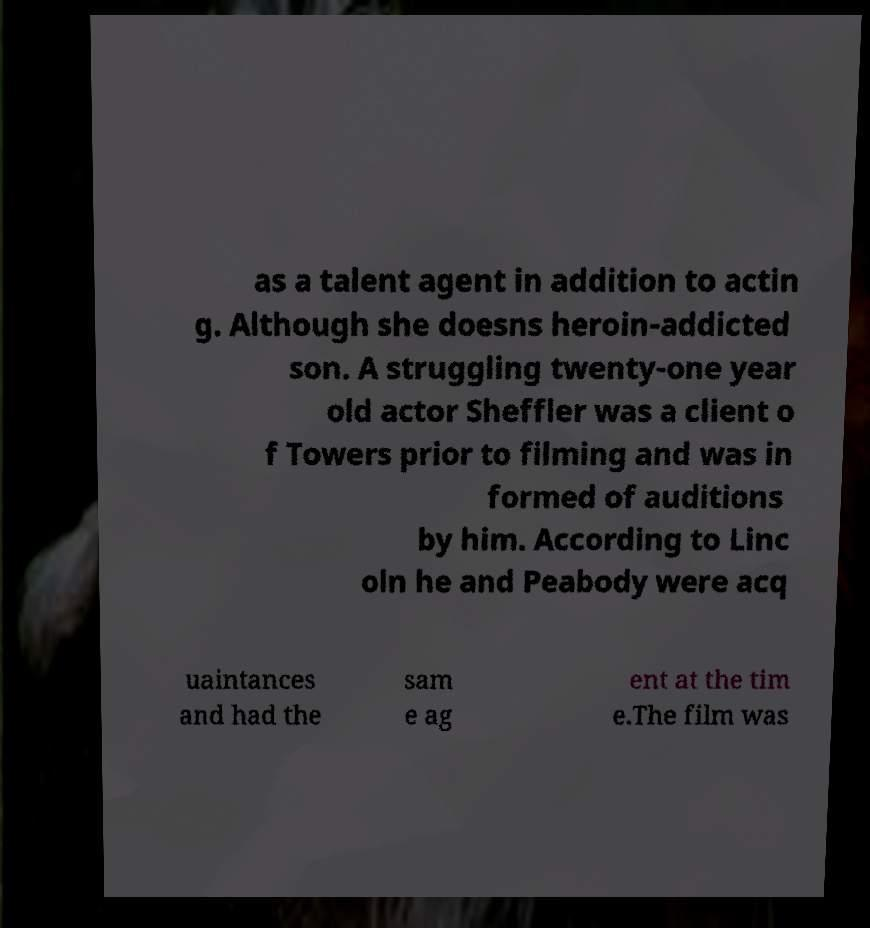What messages or text are displayed in this image? I need them in a readable, typed format. as a talent agent in addition to actin g. Although she doesns heroin-addicted son. A struggling twenty-one year old actor Sheffler was a client o f Towers prior to filming and was in formed of auditions by him. According to Linc oln he and Peabody were acq uaintances and had the sam e ag ent at the tim e.The film was 